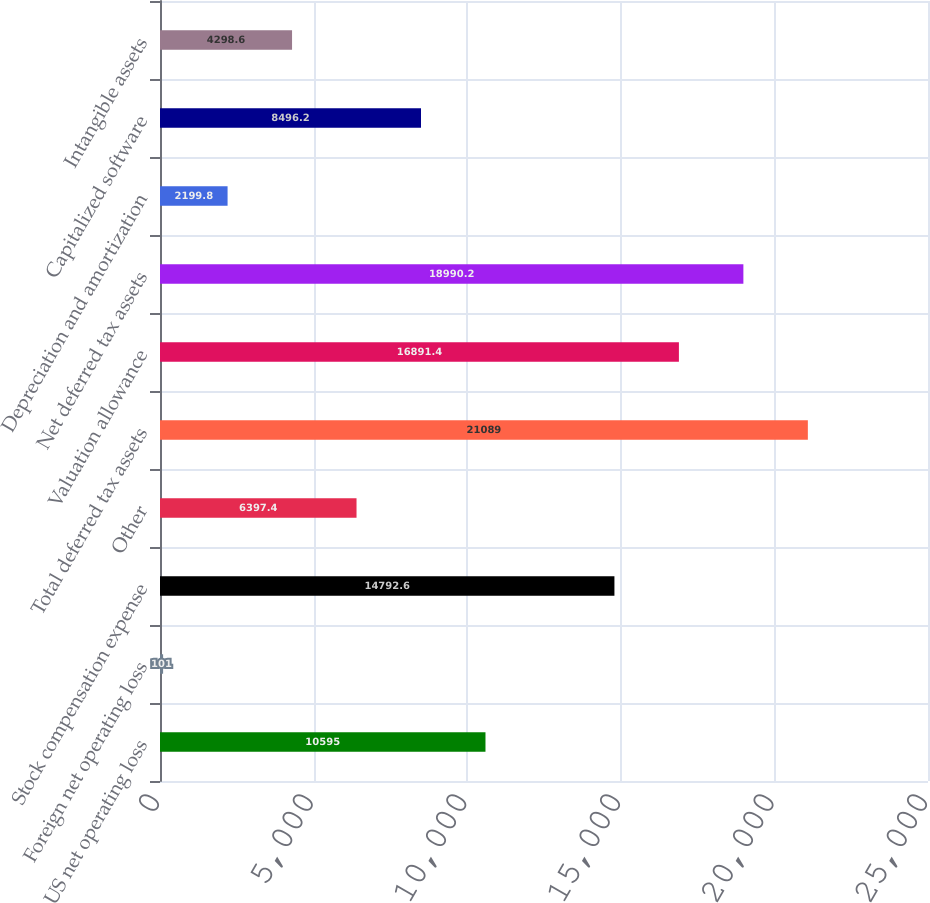<chart> <loc_0><loc_0><loc_500><loc_500><bar_chart><fcel>US net operating loss<fcel>Foreign net operating loss<fcel>Stock compensation expense<fcel>Other<fcel>Total deferred tax assets<fcel>Valuation allowance<fcel>Net deferred tax assets<fcel>Depreciation and amortization<fcel>Capitalized software<fcel>Intangible assets<nl><fcel>10595<fcel>101<fcel>14792.6<fcel>6397.4<fcel>21089<fcel>16891.4<fcel>18990.2<fcel>2199.8<fcel>8496.2<fcel>4298.6<nl></chart> 